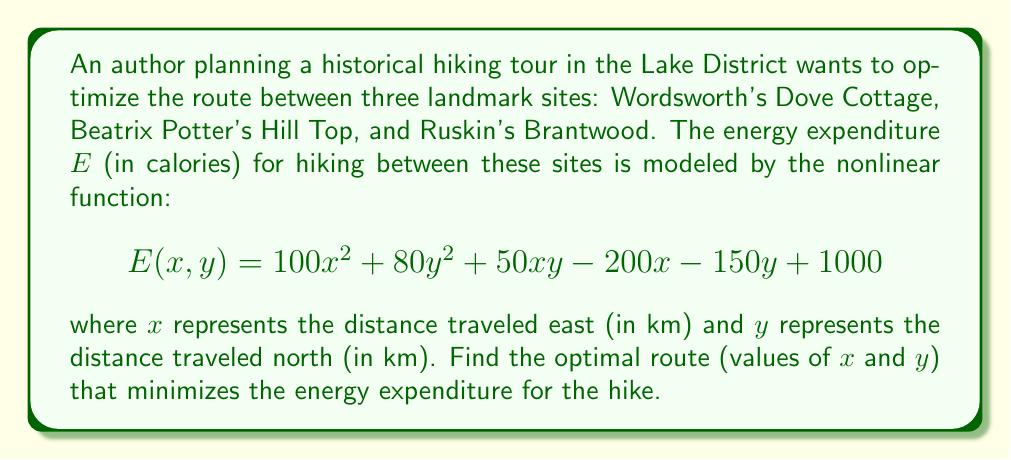Provide a solution to this math problem. To find the optimal route that minimizes energy expenditure, we need to find the minimum of the given nonlinear function $E(x, y)$. We can do this by following these steps:

1. Calculate the partial derivatives of $E$ with respect to $x$ and $y$:

   $$\frac{\partial E}{\partial x} = 200x + 50y - 200$$
   $$\frac{\partial E}{\partial y} = 160y + 50x - 150$$

2. Set both partial derivatives to zero to find the critical points:

   $$200x + 50y - 200 = 0 \quad (1)$$
   $$160y + 50x - 150 = 0 \quad (2)$$

3. Solve this system of equations:
   Multiply equation (1) by 8 and equation (2) by 5:

   $$1600x + 400y - 1600 = 0 \quad (3)$$
   $$800y + 250x - 750 = 0 \quad (4)$$

   Subtract equation (4) from equation (3):

   $$1350x - 400y - 850 = 0 \quad (5)$$

4. From equation (5), express $y$ in terms of $x$:

   $$y = \frac{1350x - 850}{400} \quad (6)$$

5. Substitute this expression for $y$ into equation (1):

   $$200x + 50(\frac{1350x - 850}{400}) - 200 = 0$$

6. Solve for $x$:

   $$200x + \frac{67500x - 42500}{400} - 200 = 0$$
   $$80000x + 67500x - 42500 - 80000 = 0$$
   $$147500x = 122500$$
   $$x = \frac{122500}{147500} = \frac{49}{59} \approx 0.831$$

7. Substitute this value of $x$ back into equation (6) to find $y$:

   $$y = \frac{1350(\frac{49}{59}) - 850}{400} = \frac{39}{59} \approx 0.661$$

8. To confirm this is a minimum, we can check the second partial derivatives:

   $$\frac{\partial^2 E}{\partial x^2} = 200 > 0$$
   $$\frac{\partial^2 E}{\partial y^2} = 160 > 0$$
   $$\frac{\partial^2 E}{\partial x \partial y} = \frac{\partial^2 E}{\partial y \partial x} = 50$$

   The Hessian determinant is positive:
   $$200 \cdot 160 - 50^2 = 29500 > 0$$

   This confirms that the critical point is indeed a minimum.
Answer: $x = \frac{49}{59}$ km east, $y = \frac{39}{59}$ km north 